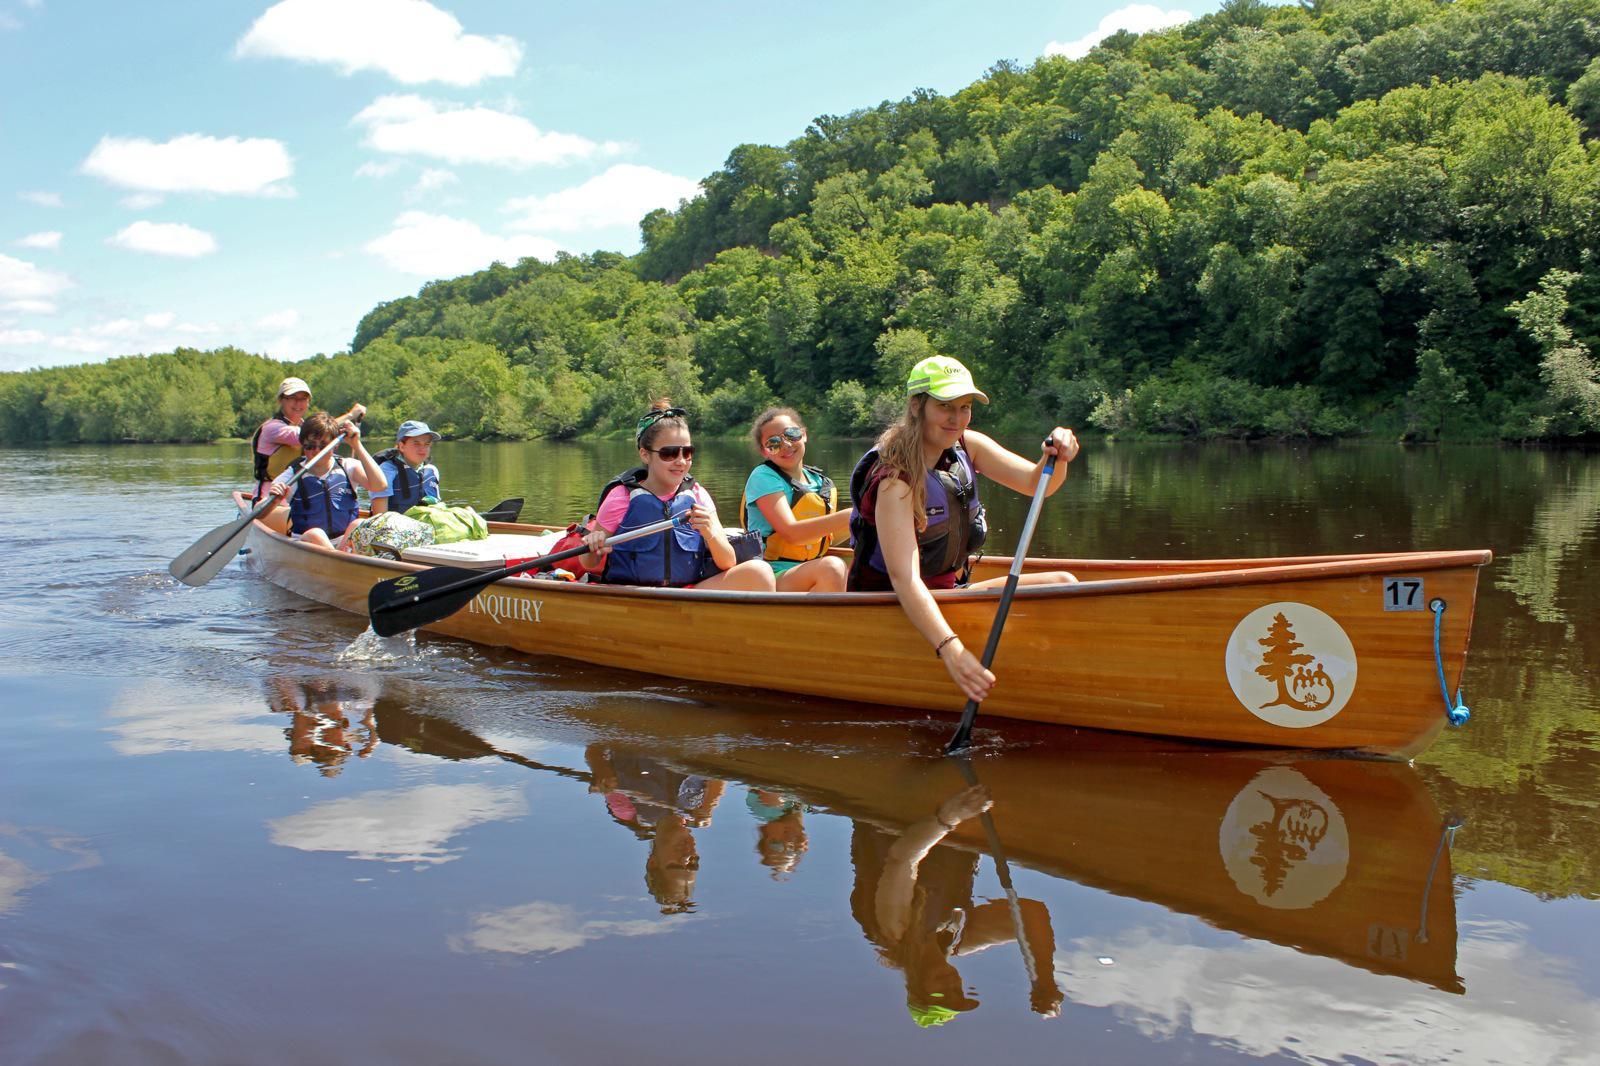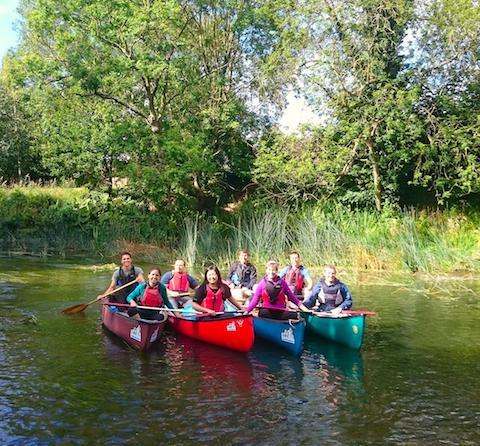The first image is the image on the left, the second image is the image on the right. Considering the images on both sides, is "The left and right image contains the same number of boats." valid? Answer yes or no. No. The first image is the image on the left, the second image is the image on the right. Analyze the images presented: Is the assertion "The left image features one light brown canoe with a white circle on its front, heading rightward with at least six people sitting in it." valid? Answer yes or no. Yes. 